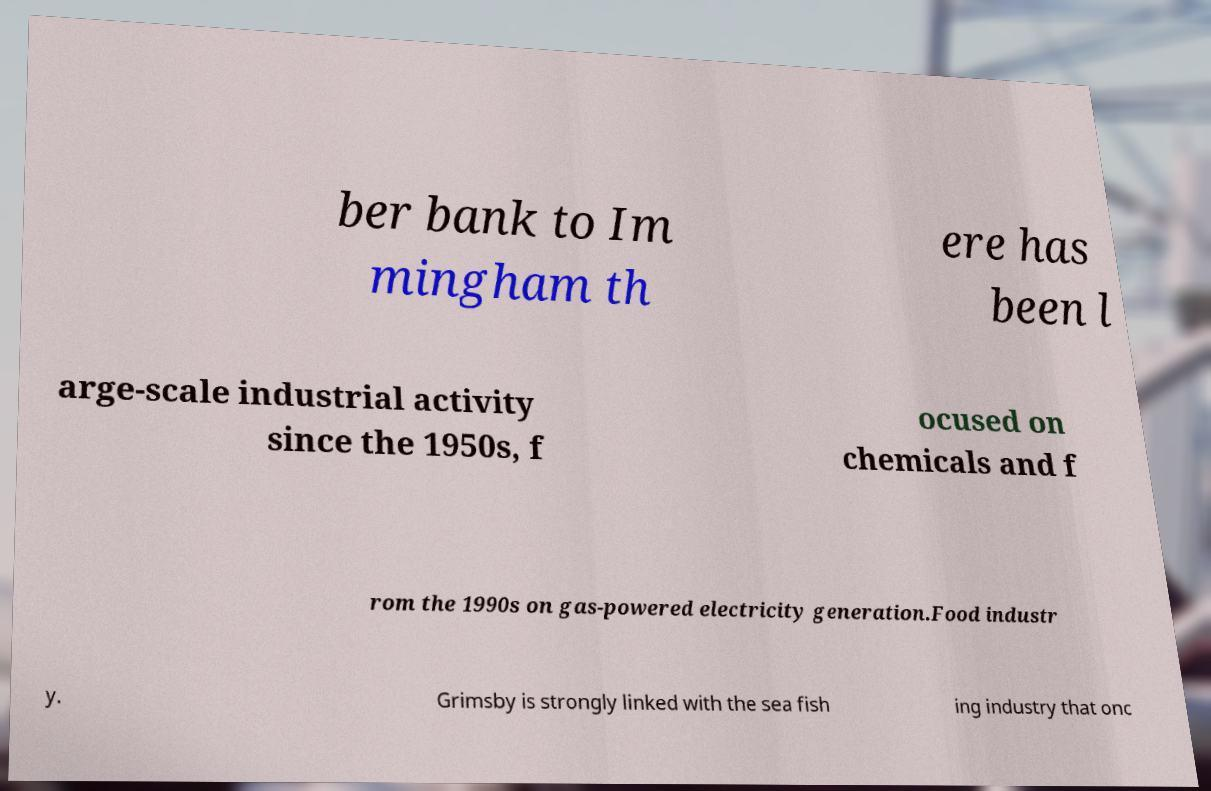For documentation purposes, I need the text within this image transcribed. Could you provide that? ber bank to Im mingham th ere has been l arge-scale industrial activity since the 1950s, f ocused on chemicals and f rom the 1990s on gas-powered electricity generation.Food industr y. Grimsby is strongly linked with the sea fish ing industry that onc 